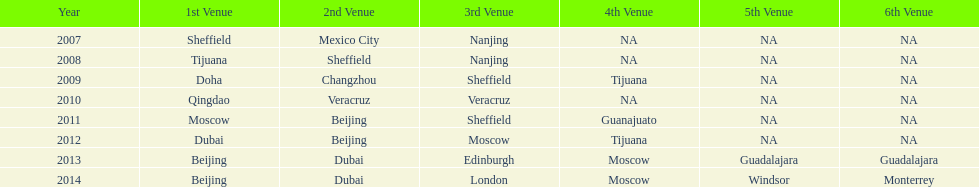Which year featured a greater number of venues, 2007 or 2012? 2012. 